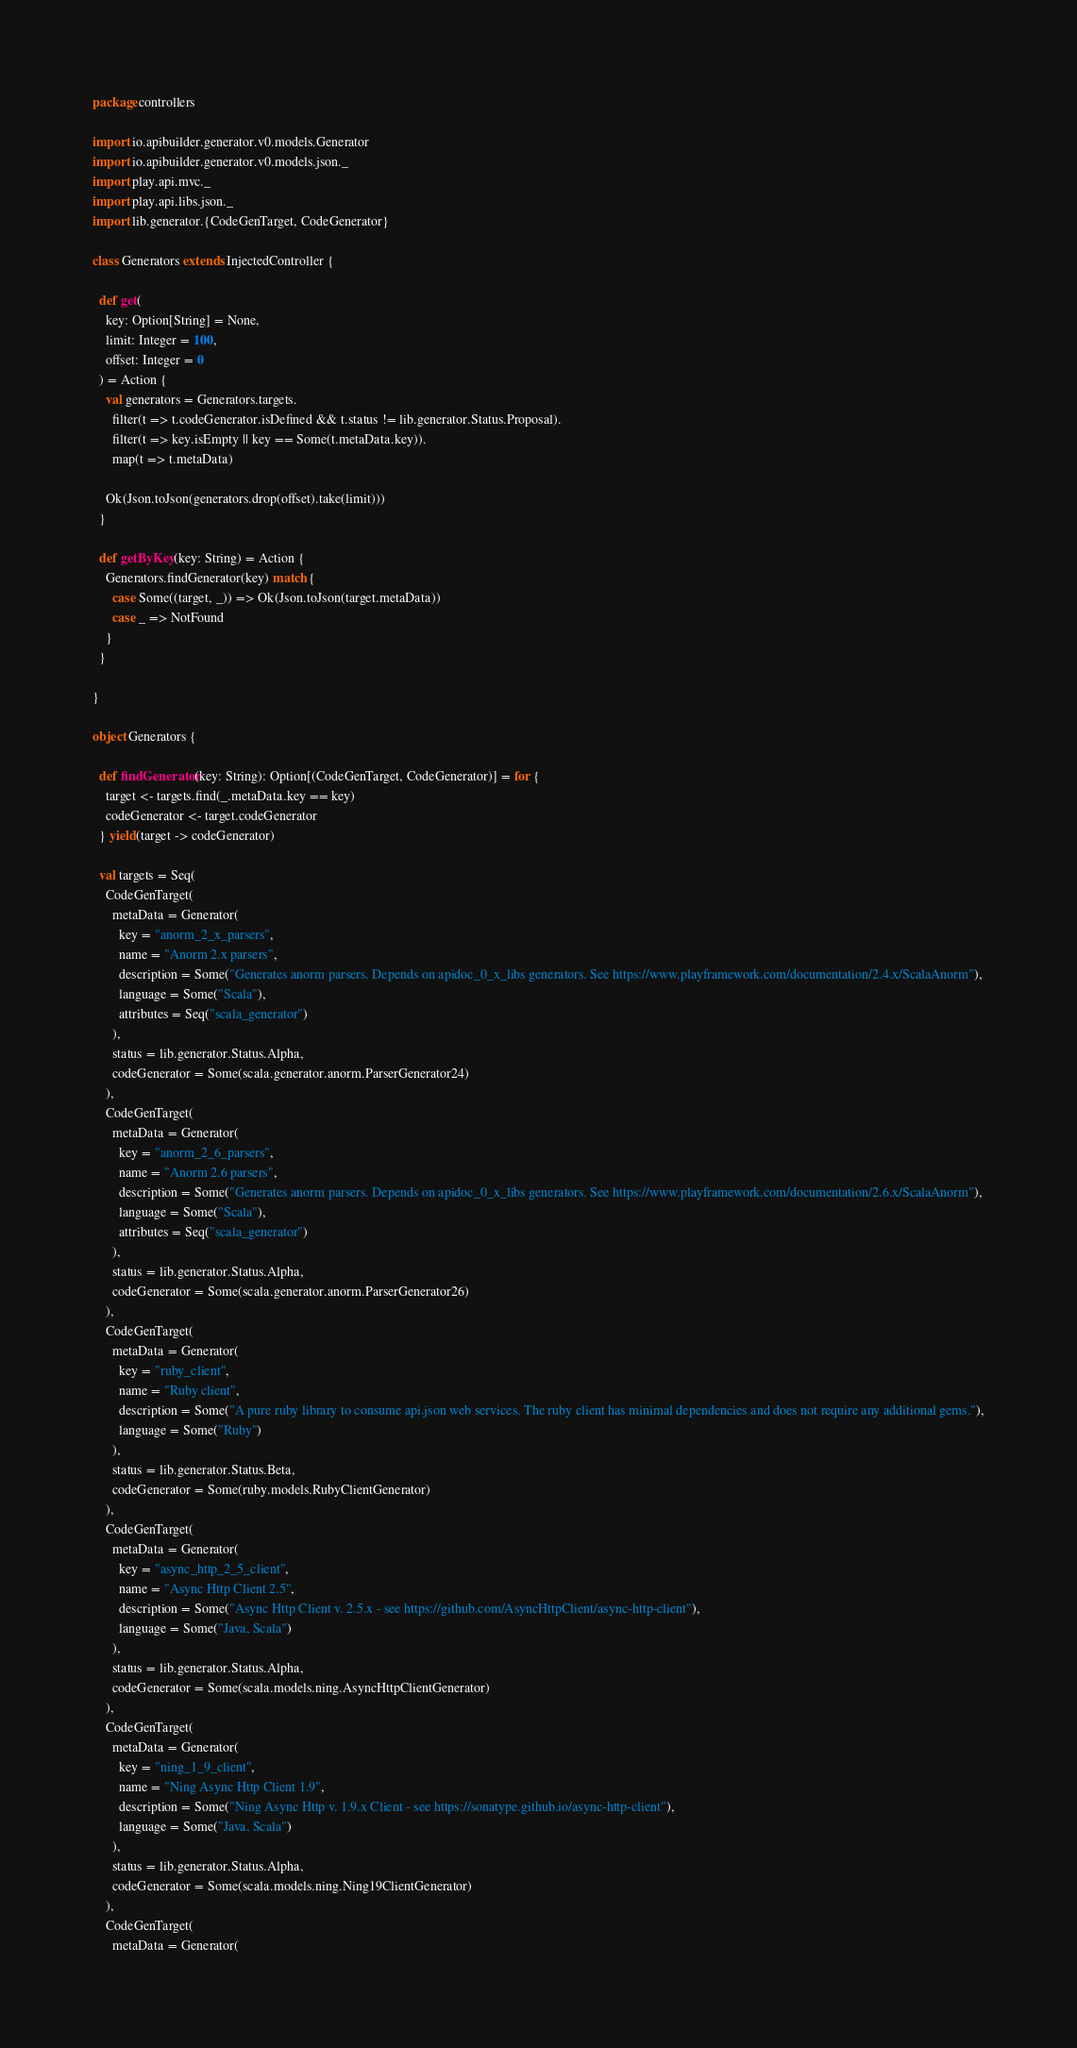<code> <loc_0><loc_0><loc_500><loc_500><_Scala_>package controllers

import io.apibuilder.generator.v0.models.Generator
import io.apibuilder.generator.v0.models.json._
import play.api.mvc._
import play.api.libs.json._
import lib.generator.{CodeGenTarget, CodeGenerator}

class Generators extends InjectedController {

  def get(
    key: Option[String] = None,
    limit: Integer = 100,
    offset: Integer = 0
  ) = Action {
    val generators = Generators.targets.
      filter(t => t.codeGenerator.isDefined && t.status != lib.generator.Status.Proposal).
      filter(t => key.isEmpty || key == Some(t.metaData.key)).
      map(t => t.metaData)

    Ok(Json.toJson(generators.drop(offset).take(limit)))
  }

  def getByKey(key: String) = Action {
    Generators.findGenerator(key) match {
      case Some((target, _)) => Ok(Json.toJson(target.metaData))
      case _ => NotFound
    }
  }

}

object Generators {

  def findGenerator(key: String): Option[(CodeGenTarget, CodeGenerator)] = for {
    target <- targets.find(_.metaData.key == key)
    codeGenerator <- target.codeGenerator
  } yield(target -> codeGenerator)

  val targets = Seq(
    CodeGenTarget(
      metaData = Generator(
        key = "anorm_2_x_parsers",
        name = "Anorm 2.x parsers",
        description = Some("Generates anorm parsers. Depends on apidoc_0_x_libs generators. See https://www.playframework.com/documentation/2.4.x/ScalaAnorm"),
        language = Some("Scala"),
        attributes = Seq("scala_generator")
      ),
      status = lib.generator.Status.Alpha,
      codeGenerator = Some(scala.generator.anorm.ParserGenerator24)
    ),
    CodeGenTarget(
      metaData = Generator(
        key = "anorm_2_6_parsers",
        name = "Anorm 2.6 parsers",
        description = Some("Generates anorm parsers. Depends on apidoc_0_x_libs generators. See https://www.playframework.com/documentation/2.6.x/ScalaAnorm"),
        language = Some("Scala"),
        attributes = Seq("scala_generator")
      ),
      status = lib.generator.Status.Alpha,
      codeGenerator = Some(scala.generator.anorm.ParserGenerator26)
    ),
    CodeGenTarget(
      metaData = Generator(
        key = "ruby_client",
        name = "Ruby client",
        description = Some("A pure ruby library to consume api.json web services. The ruby client has minimal dependencies and does not require any additional gems."),
        language = Some("Ruby")
      ),
      status = lib.generator.Status.Beta,
      codeGenerator = Some(ruby.models.RubyClientGenerator)
    ),
    CodeGenTarget(
      metaData = Generator(
        key = "async_http_2_5_client",
        name = "Async Http Client 2.5",
        description = Some("Async Http Client v. 2.5.x - see https://github.com/AsyncHttpClient/async-http-client"),
        language = Some("Java, Scala")
      ),
      status = lib.generator.Status.Alpha,
      codeGenerator = Some(scala.models.ning.AsyncHttpClientGenerator)
    ),
    CodeGenTarget(
      metaData = Generator(
        key = "ning_1_9_client",
        name = "Ning Async Http Client 1.9",
        description = Some("Ning Async Http v. 1.9.x Client - see https://sonatype.github.io/async-http-client"),
        language = Some("Java, Scala")
      ),
      status = lib.generator.Status.Alpha,
      codeGenerator = Some(scala.models.ning.Ning19ClientGenerator)
    ),
    CodeGenTarget(
      metaData = Generator(</code> 